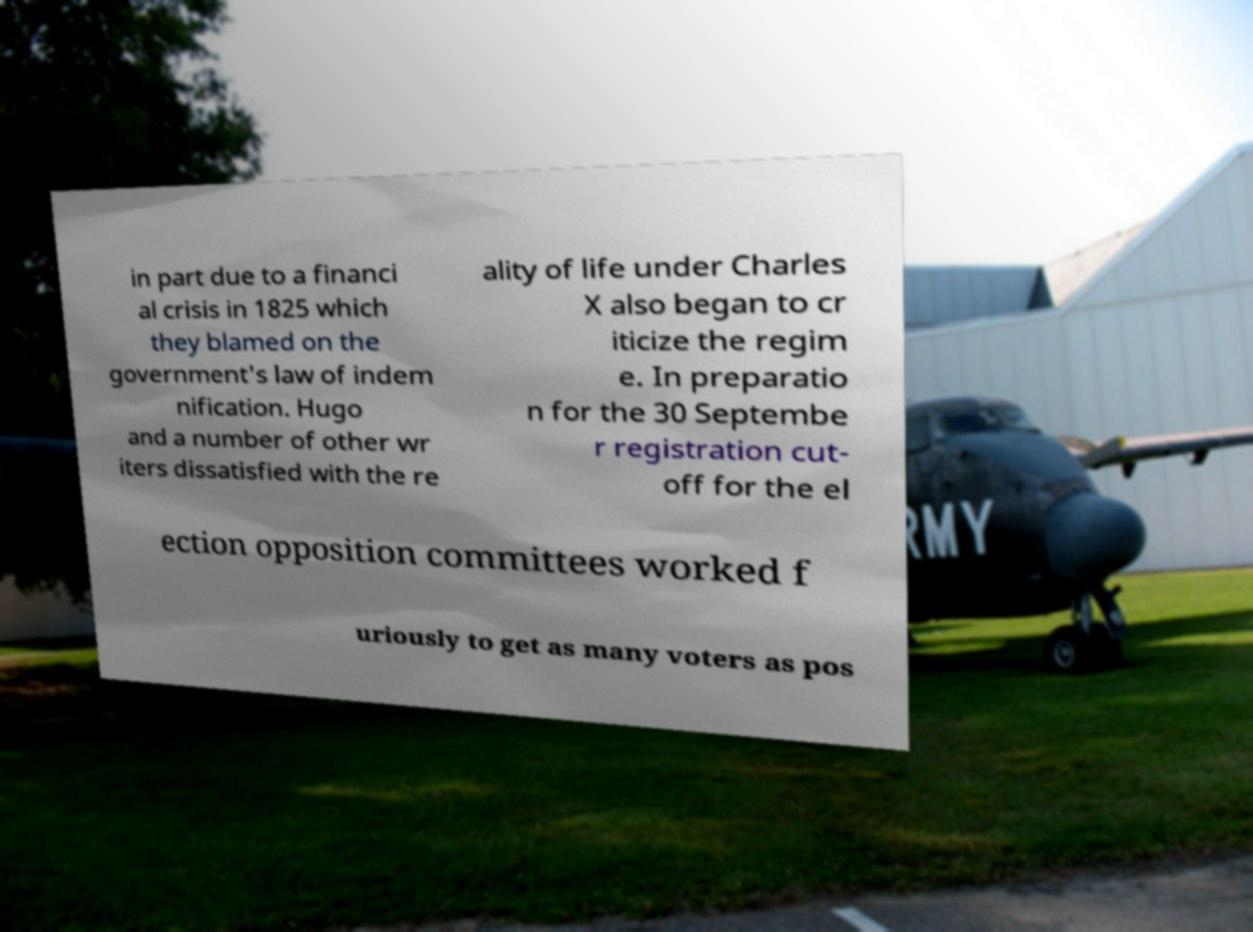Could you assist in decoding the text presented in this image and type it out clearly? in part due to a financi al crisis in 1825 which they blamed on the government's law of indem nification. Hugo and a number of other wr iters dissatisfied with the re ality of life under Charles X also began to cr iticize the regim e. In preparatio n for the 30 Septembe r registration cut- off for the el ection opposition committees worked f uriously to get as many voters as pos 